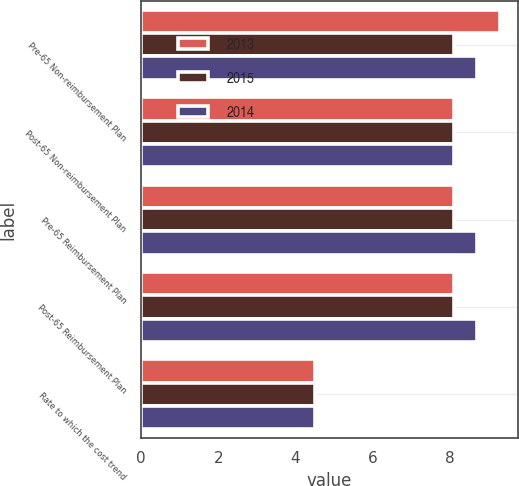Convert chart. <chart><loc_0><loc_0><loc_500><loc_500><stacked_bar_chart><ecel><fcel>Pre-65 Non-reimbursement Plan<fcel>Post-65 Non-reimbursement Plan<fcel>Pre-65 Reimbursement Plan<fcel>Post-65 Reimbursement Plan<fcel>Rate to which the cost trend<nl><fcel>2013<fcel>9.3<fcel>8.1<fcel>8.1<fcel>8.1<fcel>4.5<nl><fcel>2015<fcel>8.1<fcel>8.1<fcel>8.1<fcel>8.1<fcel>4.5<nl><fcel>2014<fcel>8.7<fcel>8.1<fcel>8.7<fcel>8.7<fcel>4.5<nl></chart> 